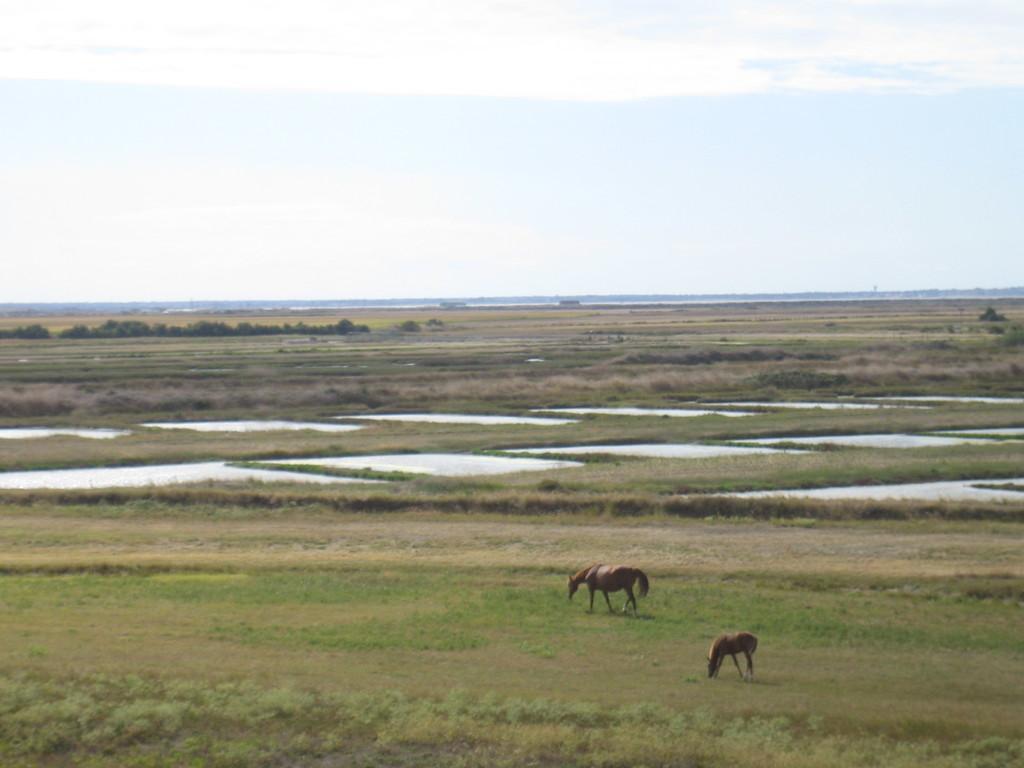In one or two sentences, can you explain what this image depicts? In this image there are two animals walking on the surface of the grass, in front of them there are a few agricultural land, in which there is water. In the background there are a few trees and the sky. 